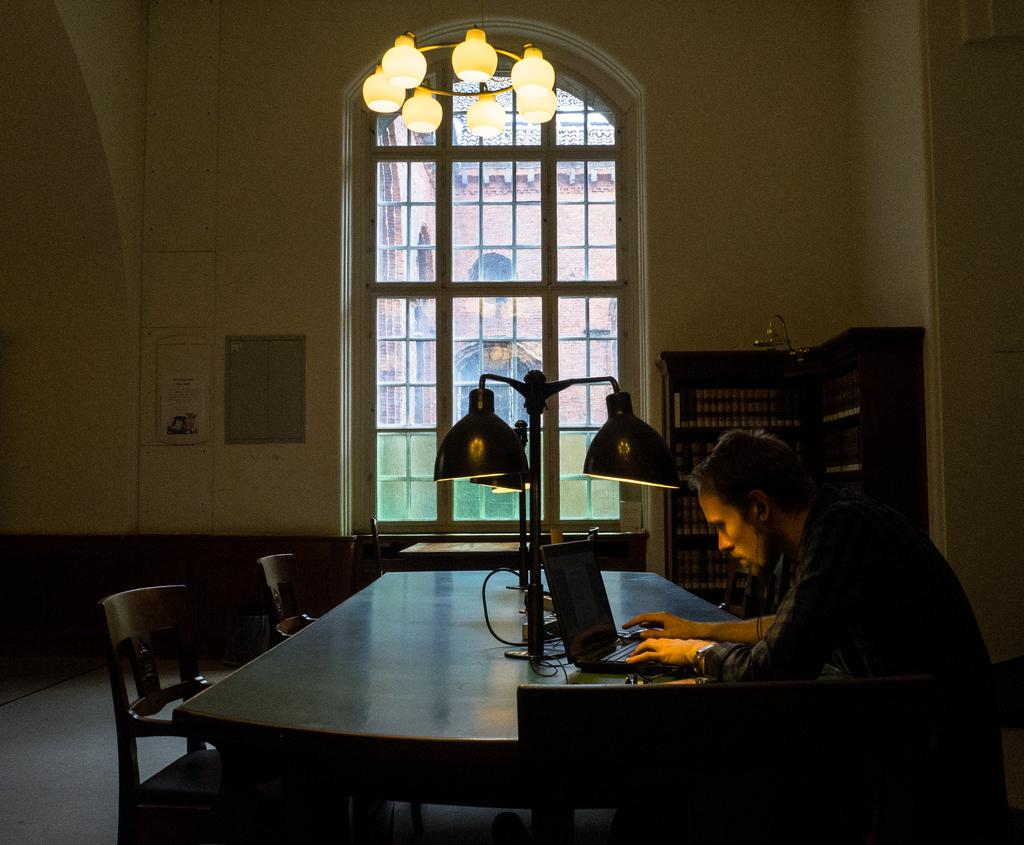What is the person in the image doing? The person is operating a laptop. What is the person wearing? The person is wearing a black shirt. What is the person's posture in the image? The person is sitting in a chair. What is connected to the laptop? Earphones are connected to the laptop. What can be seen in the background of the image? There is a window and a bookshelf in the background. What type of brush is the person using to paint the stars in the image? There is no brush or stars present in the image; the person is operating a laptop. 